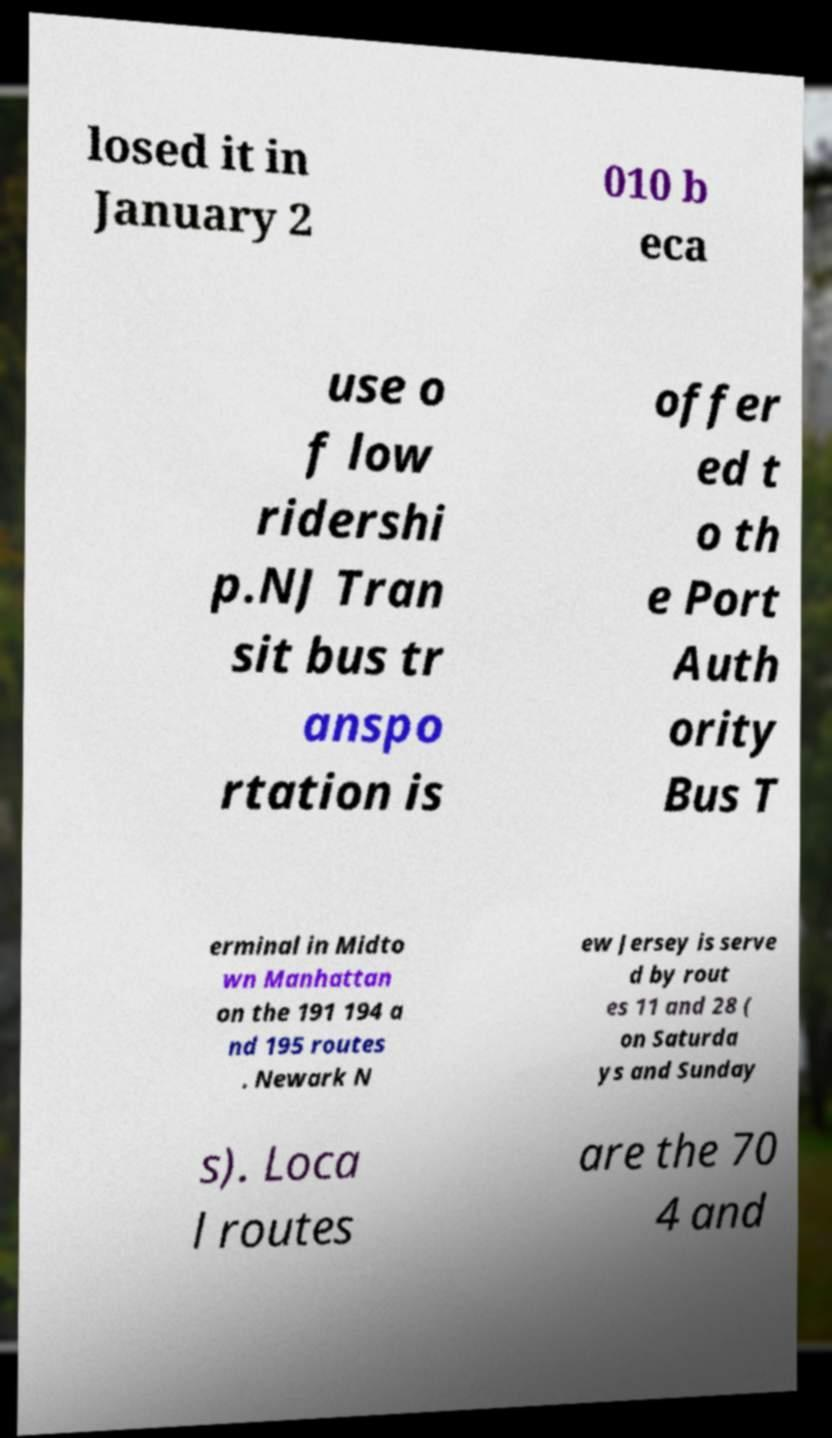Can you read and provide the text displayed in the image?This photo seems to have some interesting text. Can you extract and type it out for me? losed it in January 2 010 b eca use o f low ridershi p.NJ Tran sit bus tr anspo rtation is offer ed t o th e Port Auth ority Bus T erminal in Midto wn Manhattan on the 191 194 a nd 195 routes . Newark N ew Jersey is serve d by rout es 11 and 28 ( on Saturda ys and Sunday s). Loca l routes are the 70 4 and 